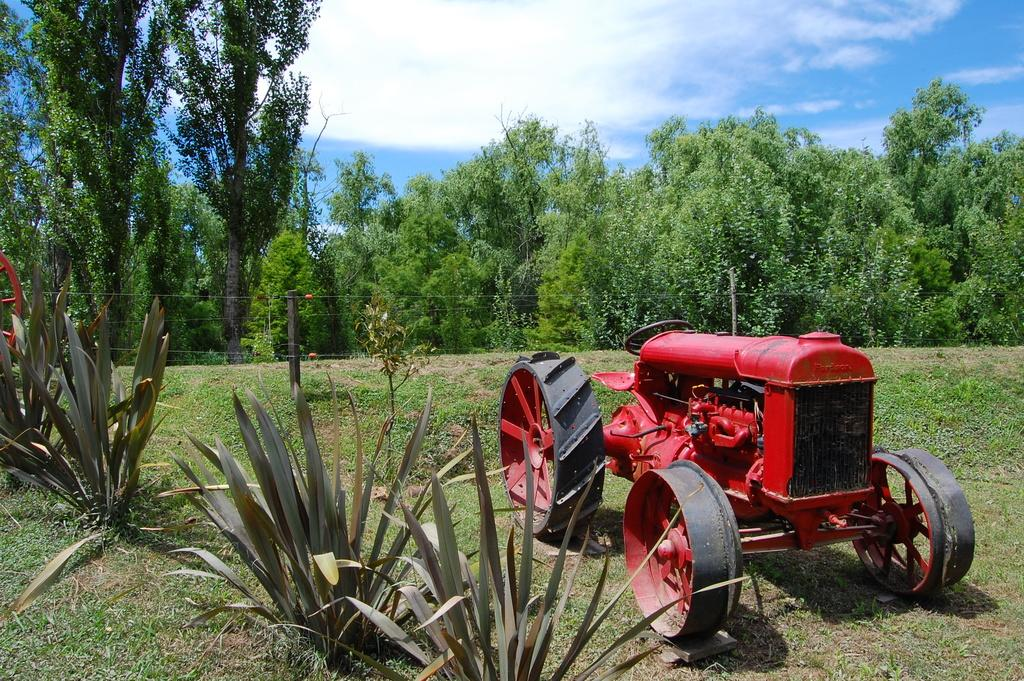What is the main object in the image? There is a vehicle in the image. Where is the vehicle located? The vehicle is on the grass. What can be seen behind the vehicle? There is a fencing behind the vehicle. What type of natural elements are present in the image? There are trees and plants in the image. What type of whip is being used to control the plants in the image? There is no whip present in the image, and the plants are not being controlled by any means. 